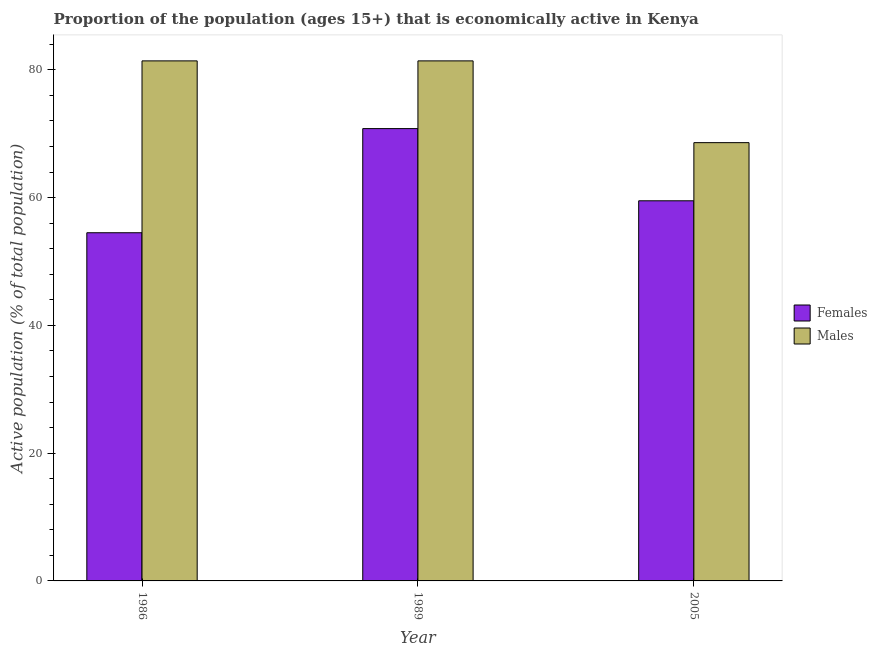How many different coloured bars are there?
Offer a very short reply. 2. How many bars are there on the 3rd tick from the left?
Offer a terse response. 2. In how many cases, is the number of bars for a given year not equal to the number of legend labels?
Make the answer very short. 0. What is the percentage of economically active female population in 2005?
Your response must be concise. 59.5. Across all years, what is the maximum percentage of economically active female population?
Your answer should be very brief. 70.8. Across all years, what is the minimum percentage of economically active female population?
Offer a very short reply. 54.5. What is the total percentage of economically active male population in the graph?
Keep it short and to the point. 231.4. What is the difference between the percentage of economically active male population in 1986 and that in 2005?
Ensure brevity in your answer.  12.8. What is the difference between the percentage of economically active female population in 2005 and the percentage of economically active male population in 1989?
Offer a very short reply. -11.3. What is the average percentage of economically active male population per year?
Give a very brief answer. 77.13. In how many years, is the percentage of economically active female population greater than 60 %?
Make the answer very short. 1. What is the ratio of the percentage of economically active male population in 1986 to that in 2005?
Offer a terse response. 1.19. What is the difference between the highest and the lowest percentage of economically active female population?
Keep it short and to the point. 16.3. In how many years, is the percentage of economically active male population greater than the average percentage of economically active male population taken over all years?
Your response must be concise. 2. What does the 1st bar from the left in 1986 represents?
Your response must be concise. Females. What does the 2nd bar from the right in 2005 represents?
Provide a succinct answer. Females. How many years are there in the graph?
Ensure brevity in your answer.  3. Does the graph contain grids?
Give a very brief answer. No. How are the legend labels stacked?
Your answer should be very brief. Vertical. What is the title of the graph?
Make the answer very short. Proportion of the population (ages 15+) that is economically active in Kenya. What is the label or title of the X-axis?
Make the answer very short. Year. What is the label or title of the Y-axis?
Provide a short and direct response. Active population (% of total population). What is the Active population (% of total population) of Females in 1986?
Make the answer very short. 54.5. What is the Active population (% of total population) of Males in 1986?
Your response must be concise. 81.4. What is the Active population (% of total population) of Females in 1989?
Give a very brief answer. 70.8. What is the Active population (% of total population) of Males in 1989?
Provide a short and direct response. 81.4. What is the Active population (% of total population) of Females in 2005?
Provide a short and direct response. 59.5. What is the Active population (% of total population) of Males in 2005?
Your response must be concise. 68.6. Across all years, what is the maximum Active population (% of total population) of Females?
Ensure brevity in your answer.  70.8. Across all years, what is the maximum Active population (% of total population) in Males?
Give a very brief answer. 81.4. Across all years, what is the minimum Active population (% of total population) of Females?
Provide a short and direct response. 54.5. Across all years, what is the minimum Active population (% of total population) in Males?
Provide a short and direct response. 68.6. What is the total Active population (% of total population) in Females in the graph?
Your answer should be compact. 184.8. What is the total Active population (% of total population) of Males in the graph?
Make the answer very short. 231.4. What is the difference between the Active population (% of total population) in Females in 1986 and that in 1989?
Provide a short and direct response. -16.3. What is the difference between the Active population (% of total population) in Females in 1986 and that in 2005?
Make the answer very short. -5. What is the difference between the Active population (% of total population) of Males in 1989 and that in 2005?
Ensure brevity in your answer.  12.8. What is the difference between the Active population (% of total population) in Females in 1986 and the Active population (% of total population) in Males in 1989?
Your response must be concise. -26.9. What is the difference between the Active population (% of total population) of Females in 1986 and the Active population (% of total population) of Males in 2005?
Keep it short and to the point. -14.1. What is the difference between the Active population (% of total population) in Females in 1989 and the Active population (% of total population) in Males in 2005?
Ensure brevity in your answer.  2.2. What is the average Active population (% of total population) of Females per year?
Give a very brief answer. 61.6. What is the average Active population (% of total population) of Males per year?
Offer a terse response. 77.13. In the year 1986, what is the difference between the Active population (% of total population) in Females and Active population (% of total population) in Males?
Your answer should be very brief. -26.9. What is the ratio of the Active population (% of total population) in Females in 1986 to that in 1989?
Make the answer very short. 0.77. What is the ratio of the Active population (% of total population) in Females in 1986 to that in 2005?
Give a very brief answer. 0.92. What is the ratio of the Active population (% of total population) of Males in 1986 to that in 2005?
Your answer should be very brief. 1.19. What is the ratio of the Active population (% of total population) of Females in 1989 to that in 2005?
Make the answer very short. 1.19. What is the ratio of the Active population (% of total population) in Males in 1989 to that in 2005?
Your answer should be very brief. 1.19. What is the difference between the highest and the second highest Active population (% of total population) of Males?
Keep it short and to the point. 0. 